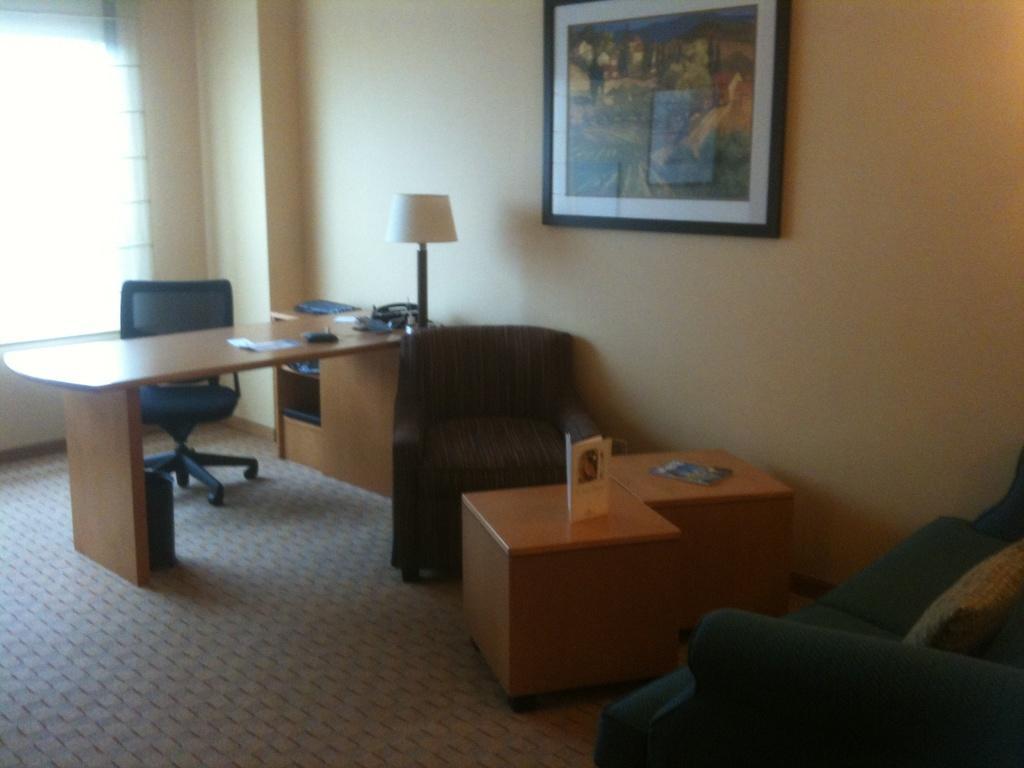How would you summarize this image in a sentence or two? In the image we can see there is a chair and in front of it there is a table on which there is a table lamp and on the wall there is a photo frame. 